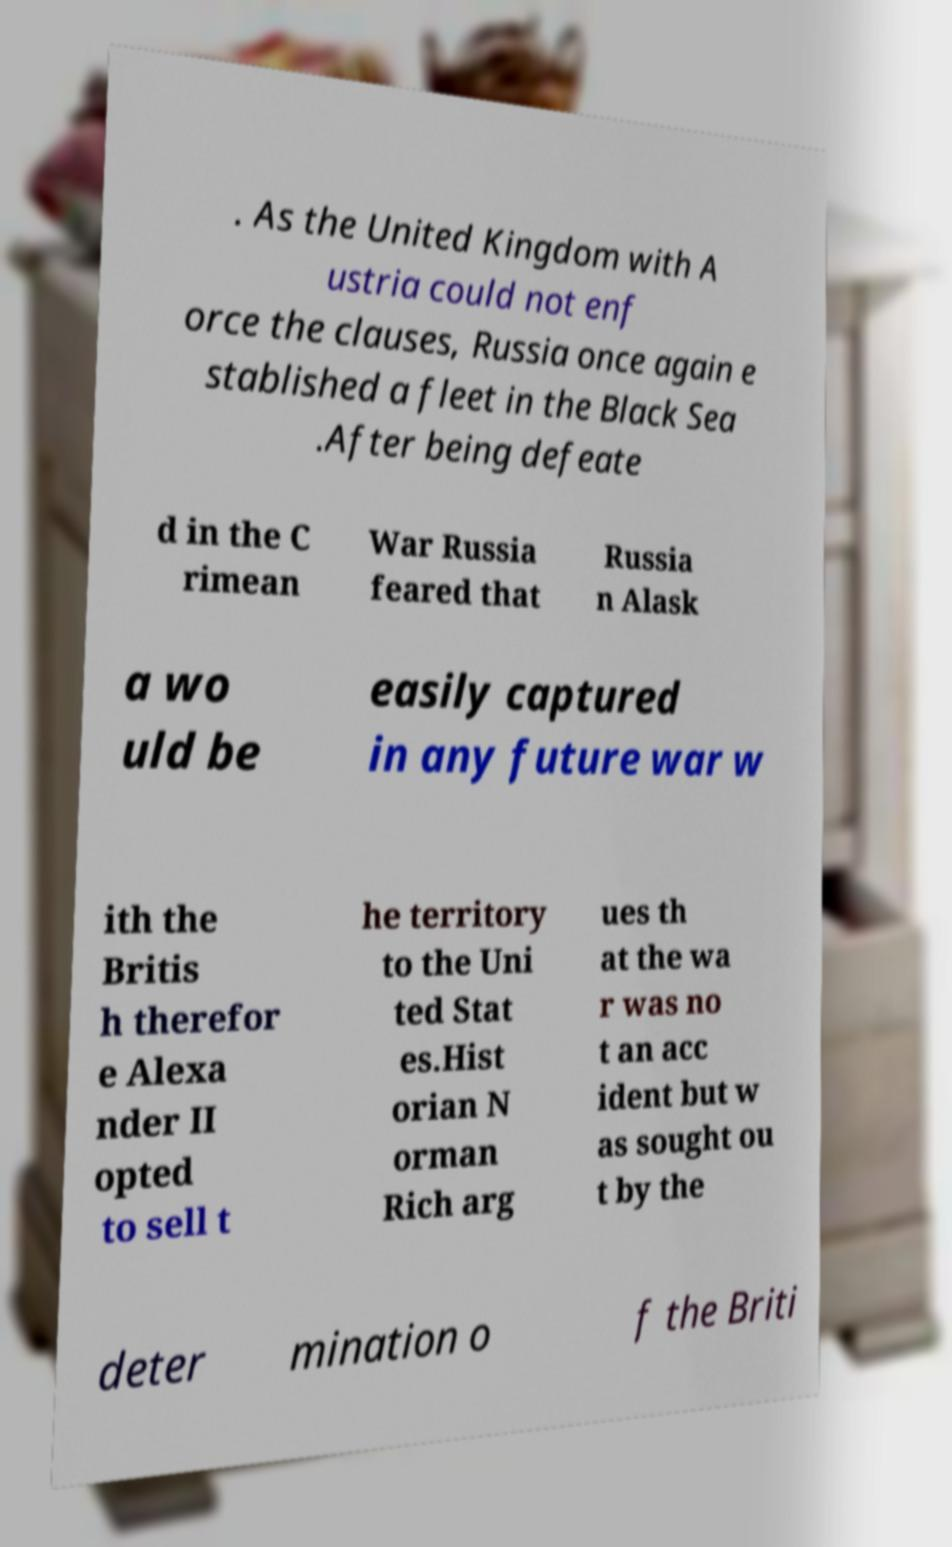Please identify and transcribe the text found in this image. . As the United Kingdom with A ustria could not enf orce the clauses, Russia once again e stablished a fleet in the Black Sea .After being defeate d in the C rimean War Russia feared that Russia n Alask a wo uld be easily captured in any future war w ith the Britis h therefor e Alexa nder II opted to sell t he territory to the Uni ted Stat es.Hist orian N orman Rich arg ues th at the wa r was no t an acc ident but w as sought ou t by the deter mination o f the Briti 